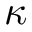<formula> <loc_0><loc_0><loc_500><loc_500>\kappa</formula> 